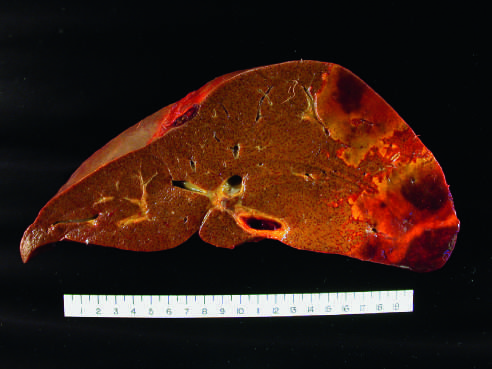what is pale, with a hemorrhagic margin?
Answer the question using a single word or phrase. The distal hepatic tissue 